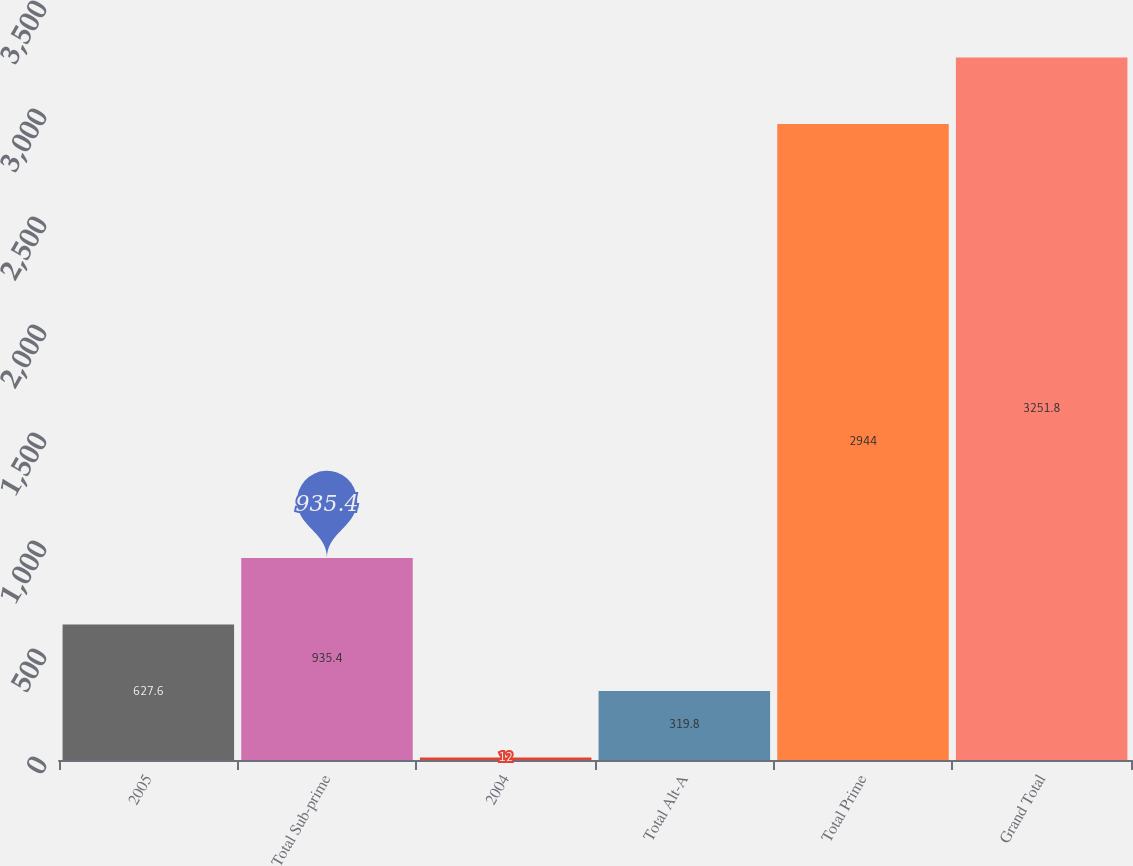Convert chart to OTSL. <chart><loc_0><loc_0><loc_500><loc_500><bar_chart><fcel>2005<fcel>Total Sub-prime<fcel>2004<fcel>Total Alt-A<fcel>Total Prime<fcel>Grand Total<nl><fcel>627.6<fcel>935.4<fcel>12<fcel>319.8<fcel>2944<fcel>3251.8<nl></chart> 